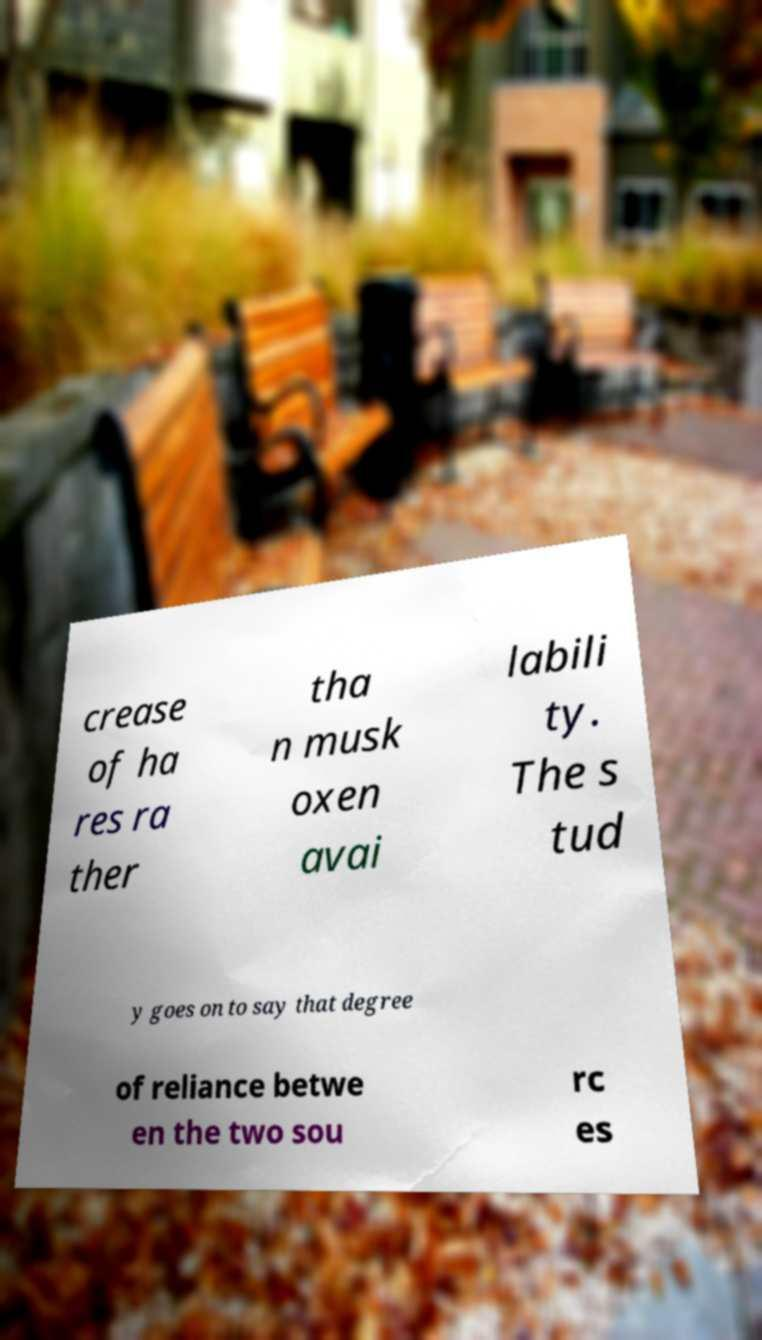Could you extract and type out the text from this image? crease of ha res ra ther tha n musk oxen avai labili ty. The s tud y goes on to say that degree of reliance betwe en the two sou rc es 